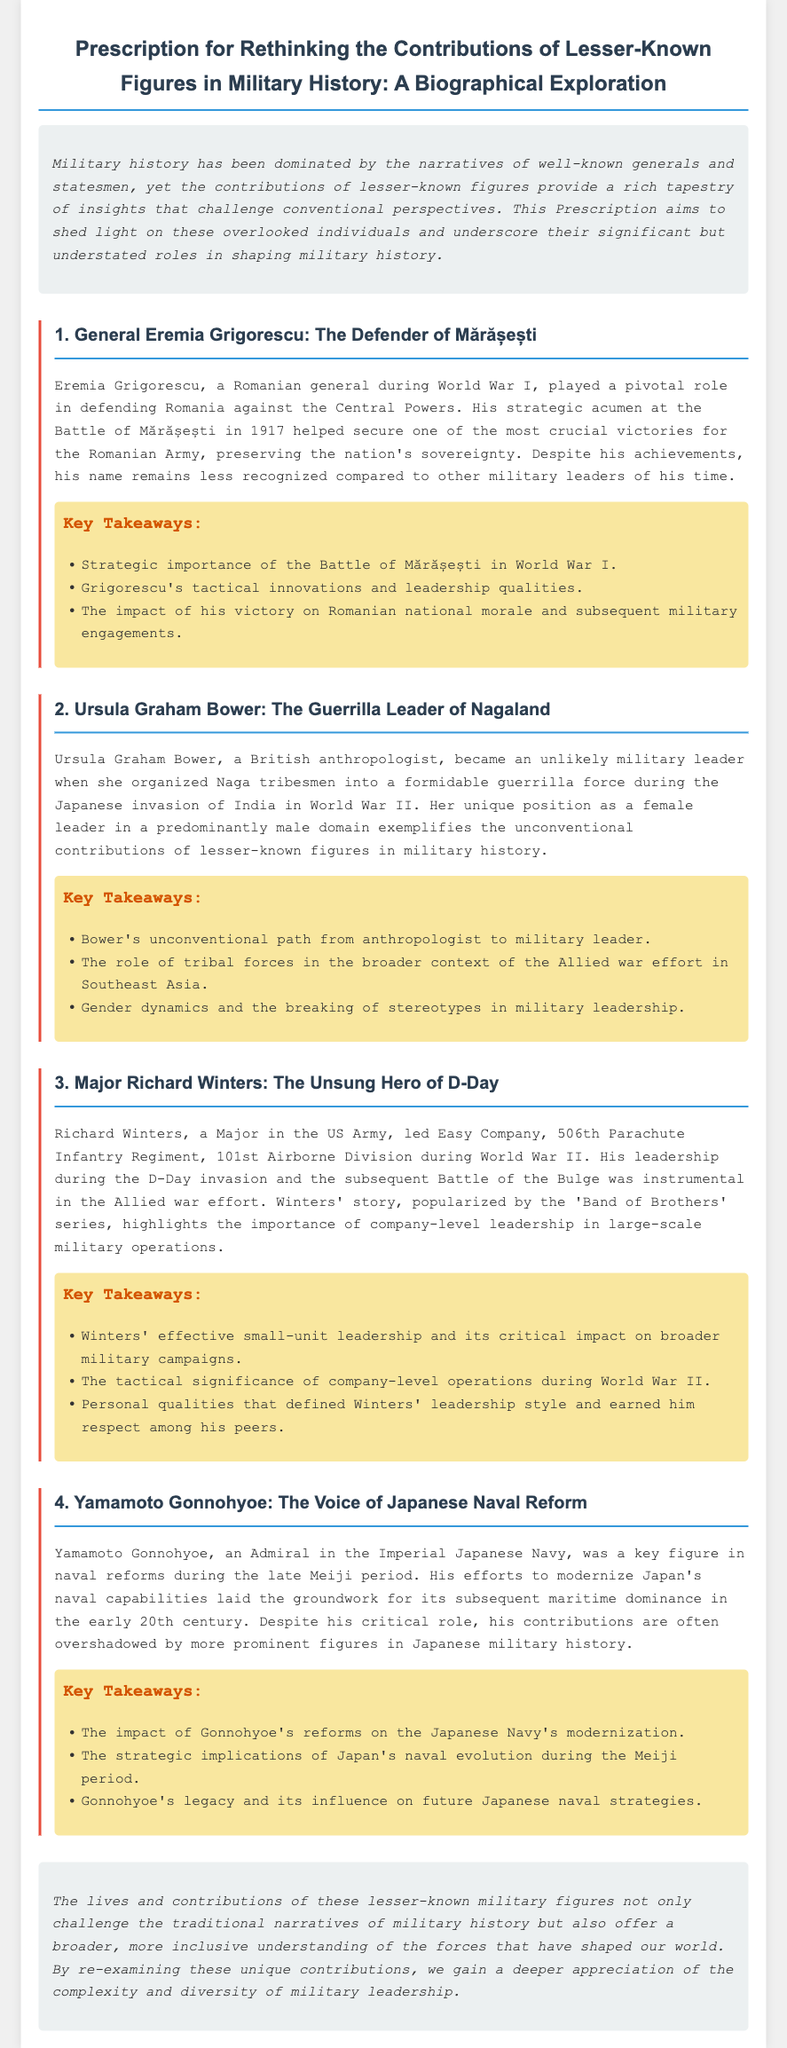What is the focus of the Prescription document? The document aims to reassess the contributions of lesser-known military figures in historical narratives, highlighting their significance in military history.
Answer: Rethinking the Contributions of Lesser-Known Figures in Military History Who was the Romanian general mentioned in the document? The document states that Eremia Grigorescu was a Romanian general during World War I noted for his role at the Battle of Mărășești.
Answer: Eremia Grigorescu What unique role did Ursula Graham Bower play during World War II? Ursula Graham Bower organized Naga tribesmen into a guerrilla force during the Japanese invasion of India.
Answer: Guerrilla leader In which battle did Richard Winters show instrumental leadership? The document highlights Richard Winters' leadership during the D-Day invasion as a pivotal moment in military history.
Answer: D-Day invasion What was Yamamoto Gonnohyoe's position in the Japanese Navy? Yamamoto Gonnohyoe held the rank of Admiral in the Imperial Japanese Navy and contributed to its modernization.
Answer: Admiral What impact did Grigorescu's victory have on Romania? The document mentions that Grigorescu's victory at Mărășești had a significant impact on national morale and military engagements.
Answer: National morale How does the document categorize the individuals discussed? The document discusses the individuals as lesser-known figures who made significant contributions to military history.
Answer: Lesser-known figures What key theme is introduced in the conclusion? The conclusion emphasizes the importance of understanding the complexity and diversity of military leadership in historical narratives.
Answer: Complexity and diversity of military leadership 